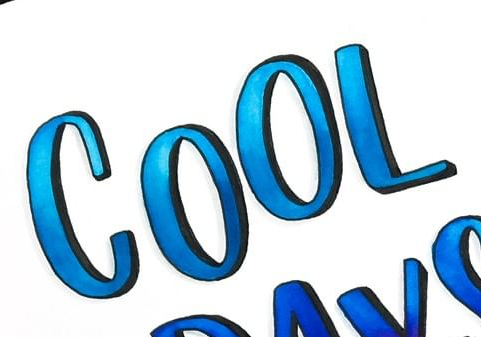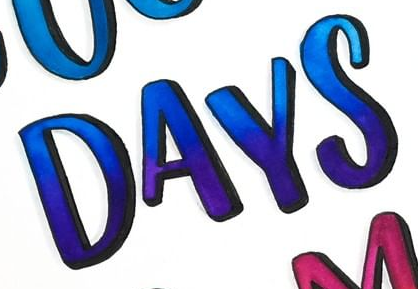Transcribe the words shown in these images in order, separated by a semicolon. COOL; DAYS 